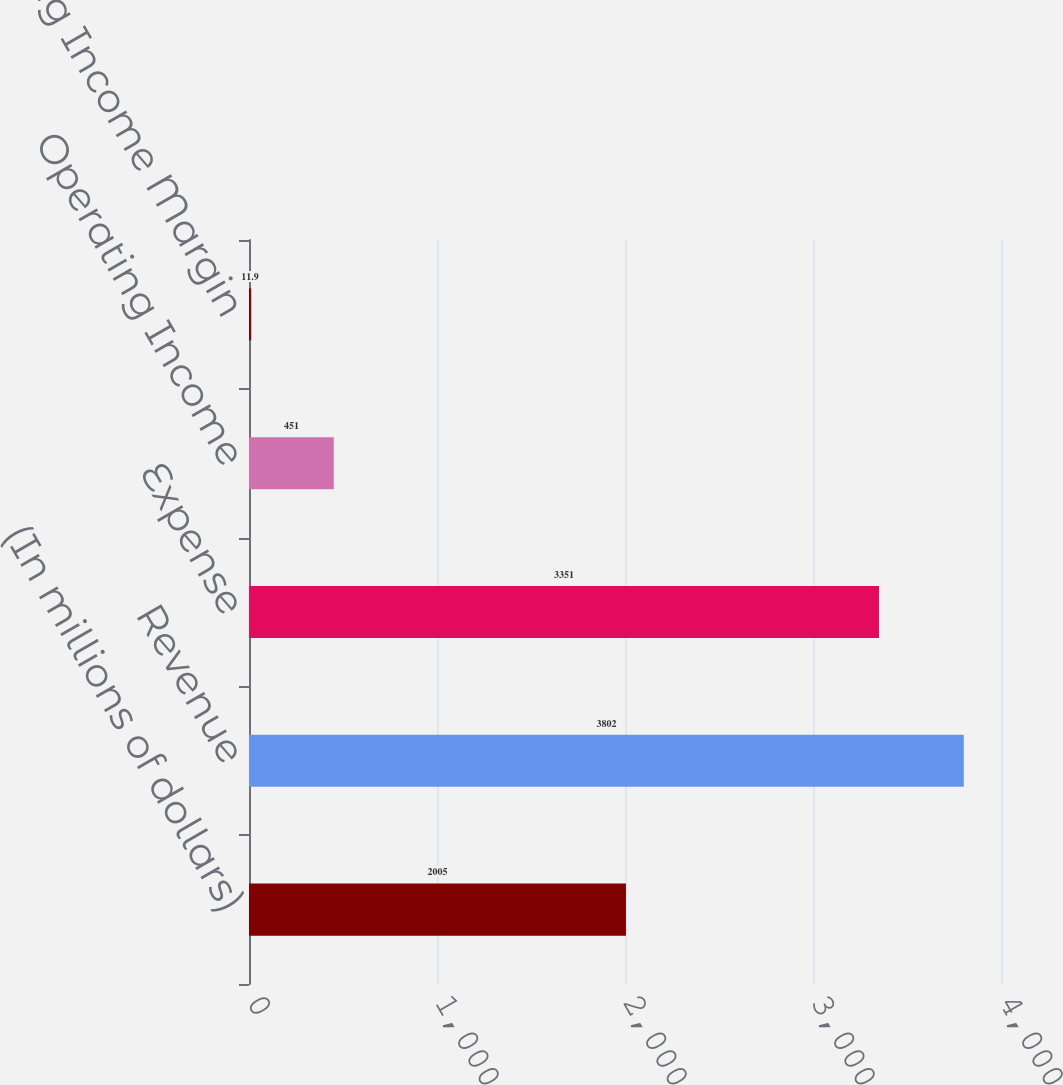Convert chart. <chart><loc_0><loc_0><loc_500><loc_500><bar_chart><fcel>(In millions of dollars)<fcel>Revenue<fcel>Expense<fcel>Operating Income<fcel>Operating Income Margin<nl><fcel>2005<fcel>3802<fcel>3351<fcel>451<fcel>11.9<nl></chart> 